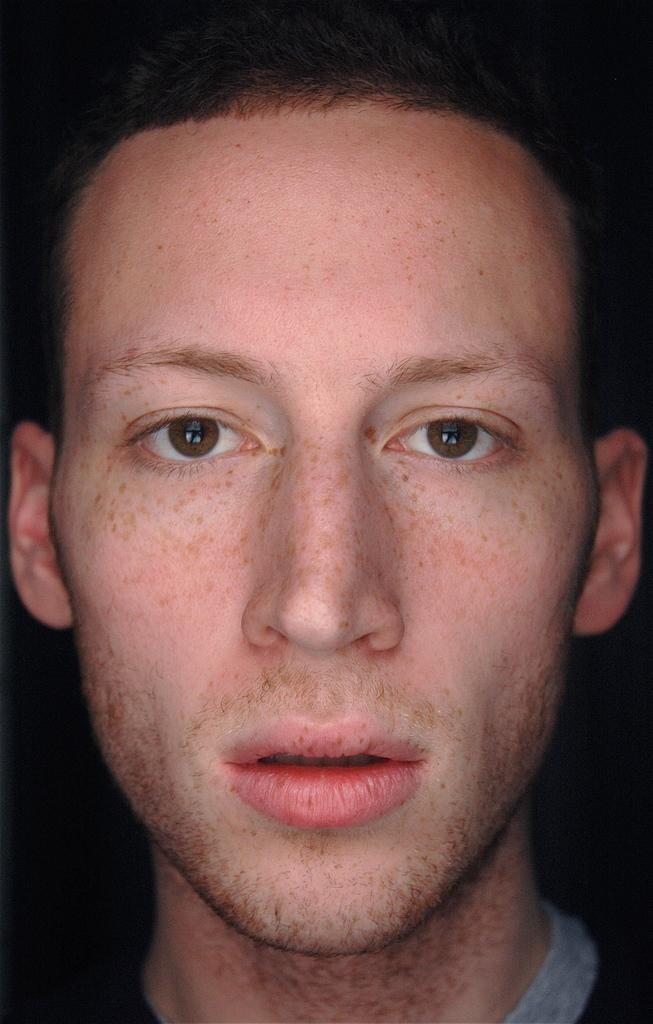How would you summarize this image in a sentence or two? In this image I can see a person. This image is taken may be in a room. 